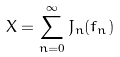Convert formula to latex. <formula><loc_0><loc_0><loc_500><loc_500>X = \sum _ { n = 0 } ^ { \infty } J _ { n } ( f _ { n } )</formula> 